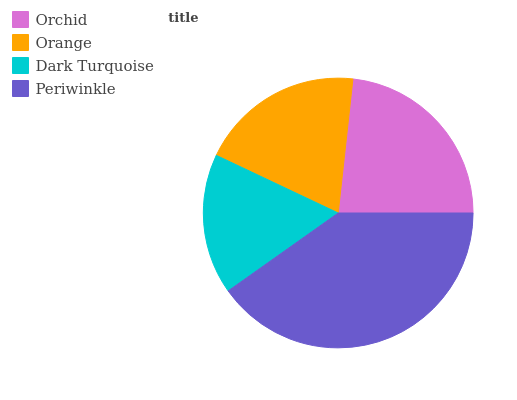Is Dark Turquoise the minimum?
Answer yes or no. Yes. Is Periwinkle the maximum?
Answer yes or no. Yes. Is Orange the minimum?
Answer yes or no. No. Is Orange the maximum?
Answer yes or no. No. Is Orchid greater than Orange?
Answer yes or no. Yes. Is Orange less than Orchid?
Answer yes or no. Yes. Is Orange greater than Orchid?
Answer yes or no. No. Is Orchid less than Orange?
Answer yes or no. No. Is Orchid the high median?
Answer yes or no. Yes. Is Orange the low median?
Answer yes or no. Yes. Is Orange the high median?
Answer yes or no. No. Is Orchid the low median?
Answer yes or no. No. 